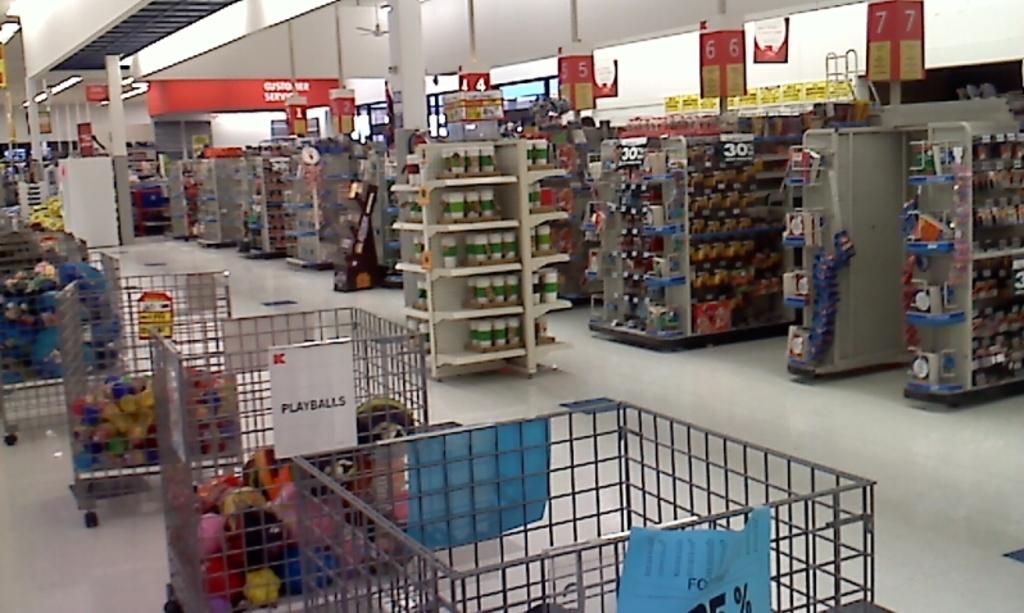<image>
Provide a brief description of the given image. inside of k-mart store and clearly visible is metal bin full of playballs 